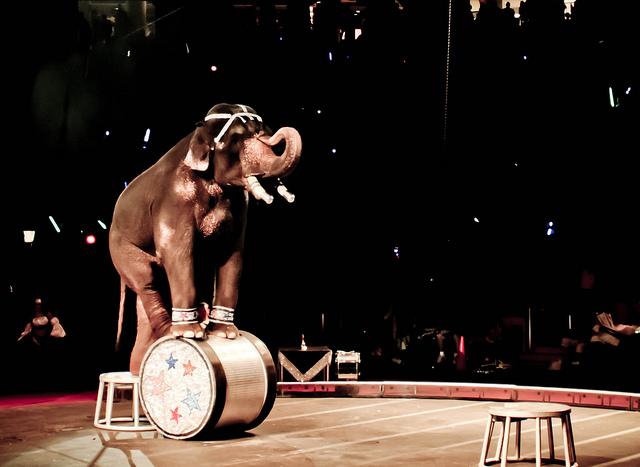Can you see the audience?
Give a very brief answer. No. Where is this?
Short answer required. Circus. What is this elephant standing?
Be succinct. Drum. 